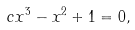Convert formula to latex. <formula><loc_0><loc_0><loc_500><loc_500>c x ^ { 3 } - x ^ { 2 } + 1 = 0 ,</formula> 